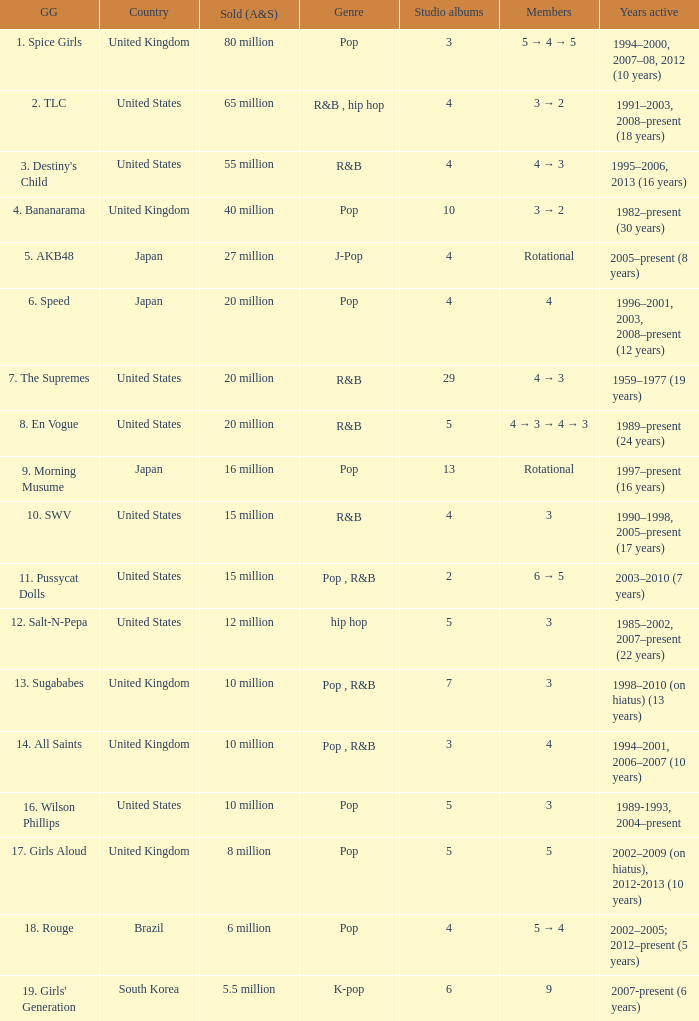How many members were in the group that sold 65 million albums and singles? 3 → 2. 